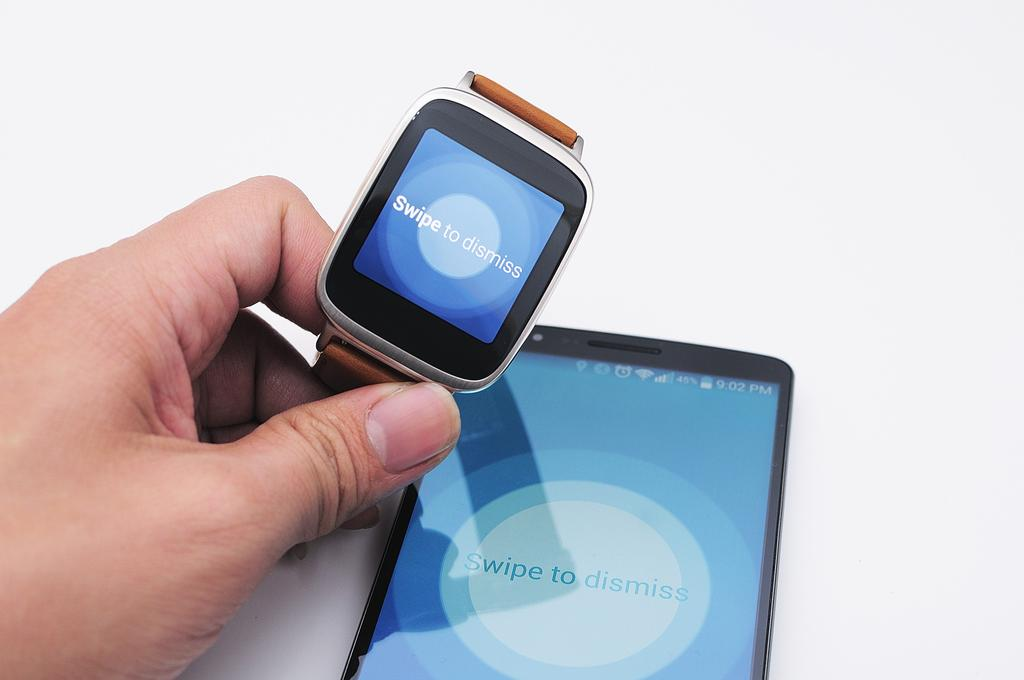<image>
Create a compact narrative representing the image presented. The watch and phone have a swipe to dismiss app. 